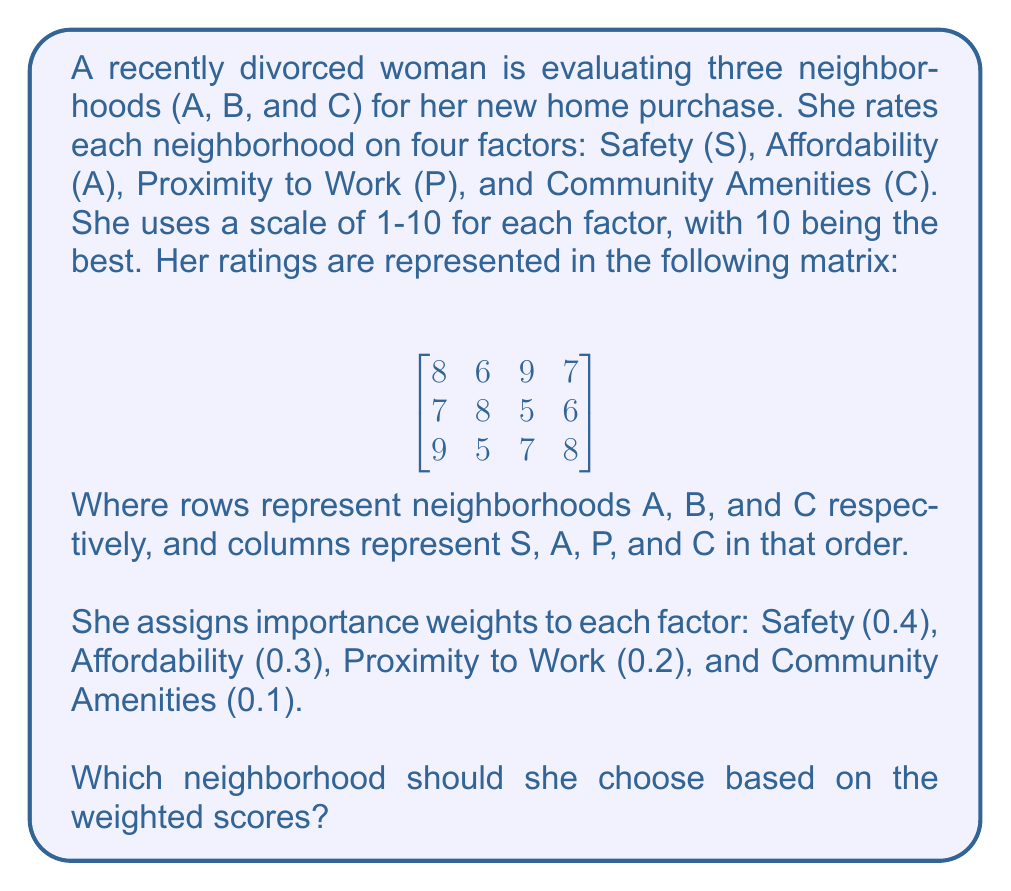Solve this math problem. To solve this problem, we need to follow these steps:

1) First, we need to create a weight vector from the given importance weights:

   $$w = \begin{bmatrix} 0.4 \\ 0.3 \\ 0.2 \\ 0.1 \end{bmatrix}$$

2) Next, we multiply the rating matrix by the weight vector. This operation can be represented as:

   $$\begin{bmatrix}
   8 & 6 & 9 & 7 \\
   7 & 8 & 5 & 6 \\
   9 & 5 & 7 & 8
   \end{bmatrix} \times
   \begin{bmatrix}
   0.4 \\ 0.3 \\ 0.2 \\ 0.1
   \end{bmatrix}$$

3) Let's perform the matrix multiplication:

   For Neighborhood A:
   $$(8 \times 0.4) + (6 \times 0.3) + (9 \times 0.2) + (7 \times 0.1) = 3.2 + 1.8 + 1.8 + 0.7 = 7.5$$

   For Neighborhood B:
   $$(7 \times 0.4) + (8 \times 0.3) + (5 \times 0.2) + (6 \times 0.1) = 2.8 + 2.4 + 1.0 + 0.6 = 6.8$$

   For Neighborhood C:
   $$(9 \times 0.4) + (5 \times 0.3) + (7 \times 0.2) + (8 \times 0.1) = 3.6 + 1.5 + 1.4 + 0.8 = 7.3$$

4) The resulting vector of weighted scores is:

   $$\begin{bmatrix}
   7.5 \\ 6.8 \\ 7.3
   \end{bmatrix}$$

5) The highest score is 7.5, which corresponds to Neighborhood A.

Therefore, based on the weighted scores, she should choose Neighborhood A.
Answer: Neighborhood A 